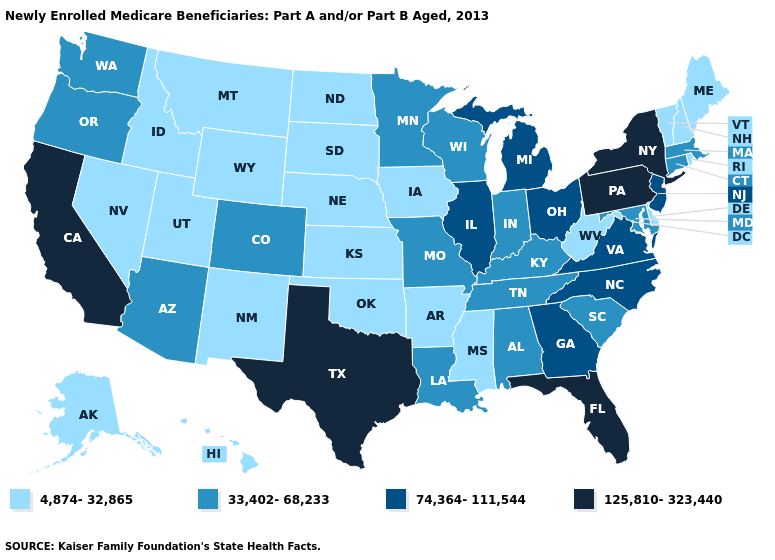Among the states that border California , does Nevada have the lowest value?
Quick response, please. Yes. Name the states that have a value in the range 4,874-32,865?
Give a very brief answer. Alaska, Arkansas, Delaware, Hawaii, Idaho, Iowa, Kansas, Maine, Mississippi, Montana, Nebraska, Nevada, New Hampshire, New Mexico, North Dakota, Oklahoma, Rhode Island, South Dakota, Utah, Vermont, West Virginia, Wyoming. Name the states that have a value in the range 33,402-68,233?
Answer briefly. Alabama, Arizona, Colorado, Connecticut, Indiana, Kentucky, Louisiana, Maryland, Massachusetts, Minnesota, Missouri, Oregon, South Carolina, Tennessee, Washington, Wisconsin. What is the value of Idaho?
Write a very short answer. 4,874-32,865. Does the map have missing data?
Short answer required. No. Among the states that border Arkansas , does Texas have the highest value?
Write a very short answer. Yes. Which states hav the highest value in the MidWest?
Quick response, please. Illinois, Michigan, Ohio. Name the states that have a value in the range 74,364-111,544?
Short answer required. Georgia, Illinois, Michigan, New Jersey, North Carolina, Ohio, Virginia. Is the legend a continuous bar?
Be succinct. No. Name the states that have a value in the range 125,810-323,440?
Answer briefly. California, Florida, New York, Pennsylvania, Texas. Name the states that have a value in the range 74,364-111,544?
Quick response, please. Georgia, Illinois, Michigan, New Jersey, North Carolina, Ohio, Virginia. Does New Hampshire have the lowest value in the USA?
Short answer required. Yes. What is the value of Delaware?
Quick response, please. 4,874-32,865. Does Colorado have the highest value in the West?
Write a very short answer. No. 